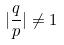Convert formula to latex. <formula><loc_0><loc_0><loc_500><loc_500>| \frac { q } { p } | \ne 1</formula> 